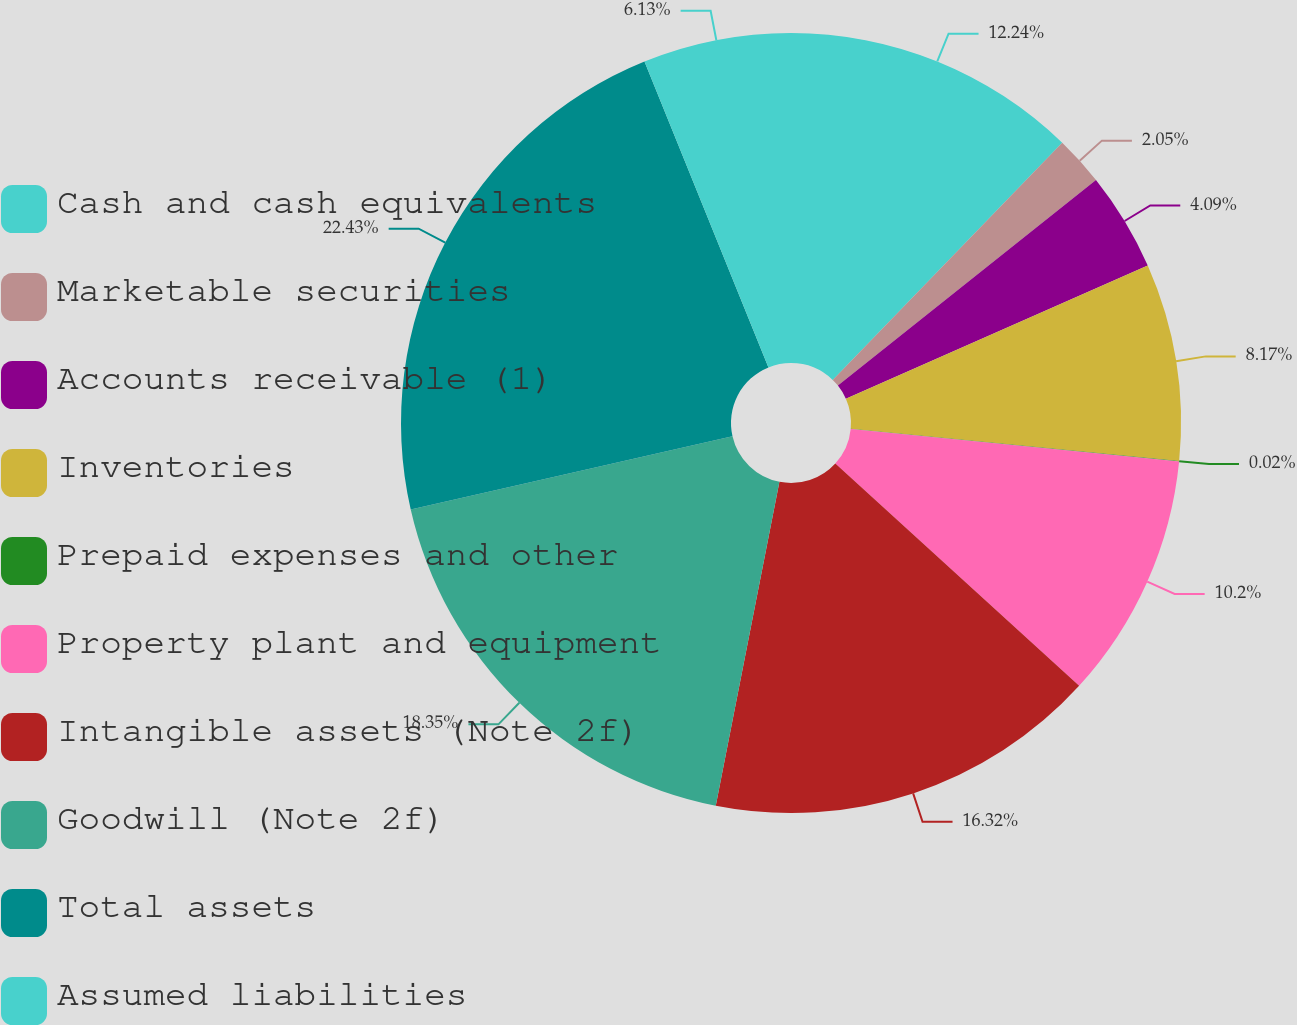Convert chart. <chart><loc_0><loc_0><loc_500><loc_500><pie_chart><fcel>Cash and cash equivalents<fcel>Marketable securities<fcel>Accounts receivable (1)<fcel>Inventories<fcel>Prepaid expenses and other<fcel>Property plant and equipment<fcel>Intangible assets (Note 2f)<fcel>Goodwill (Note 2f)<fcel>Total assets<fcel>Assumed liabilities<nl><fcel>12.24%<fcel>2.05%<fcel>4.09%<fcel>8.17%<fcel>0.02%<fcel>10.2%<fcel>16.32%<fcel>18.35%<fcel>22.43%<fcel>6.13%<nl></chart> 